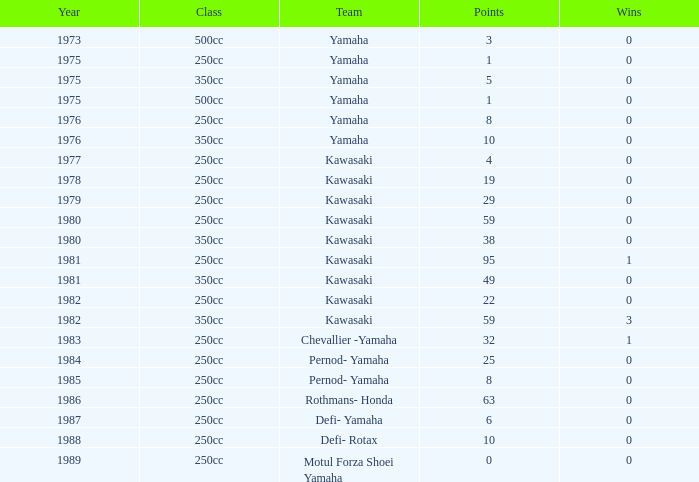What is the average year number with over 0 victories, the category is 250cc, and the score is 95? 1981.0. 